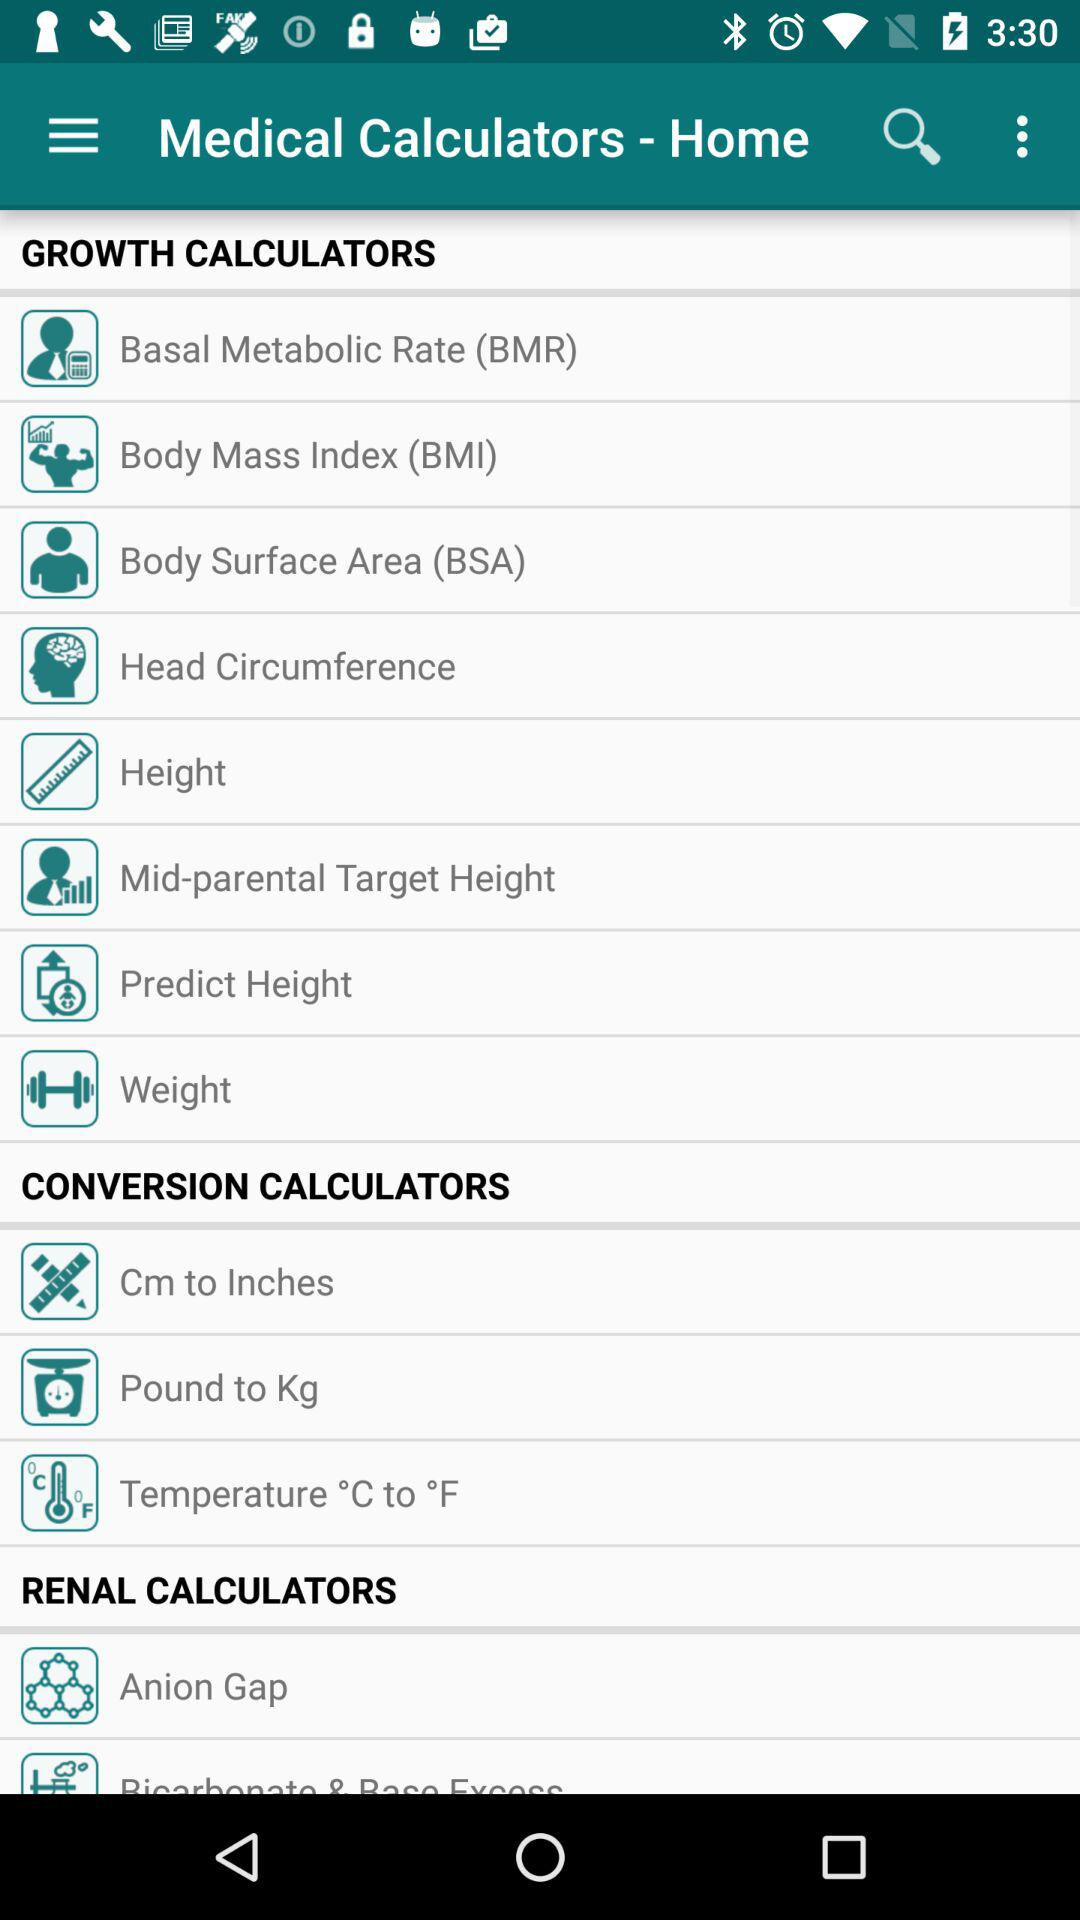How many renal calculators are there?
Answer the question using a single word or phrase. 2 